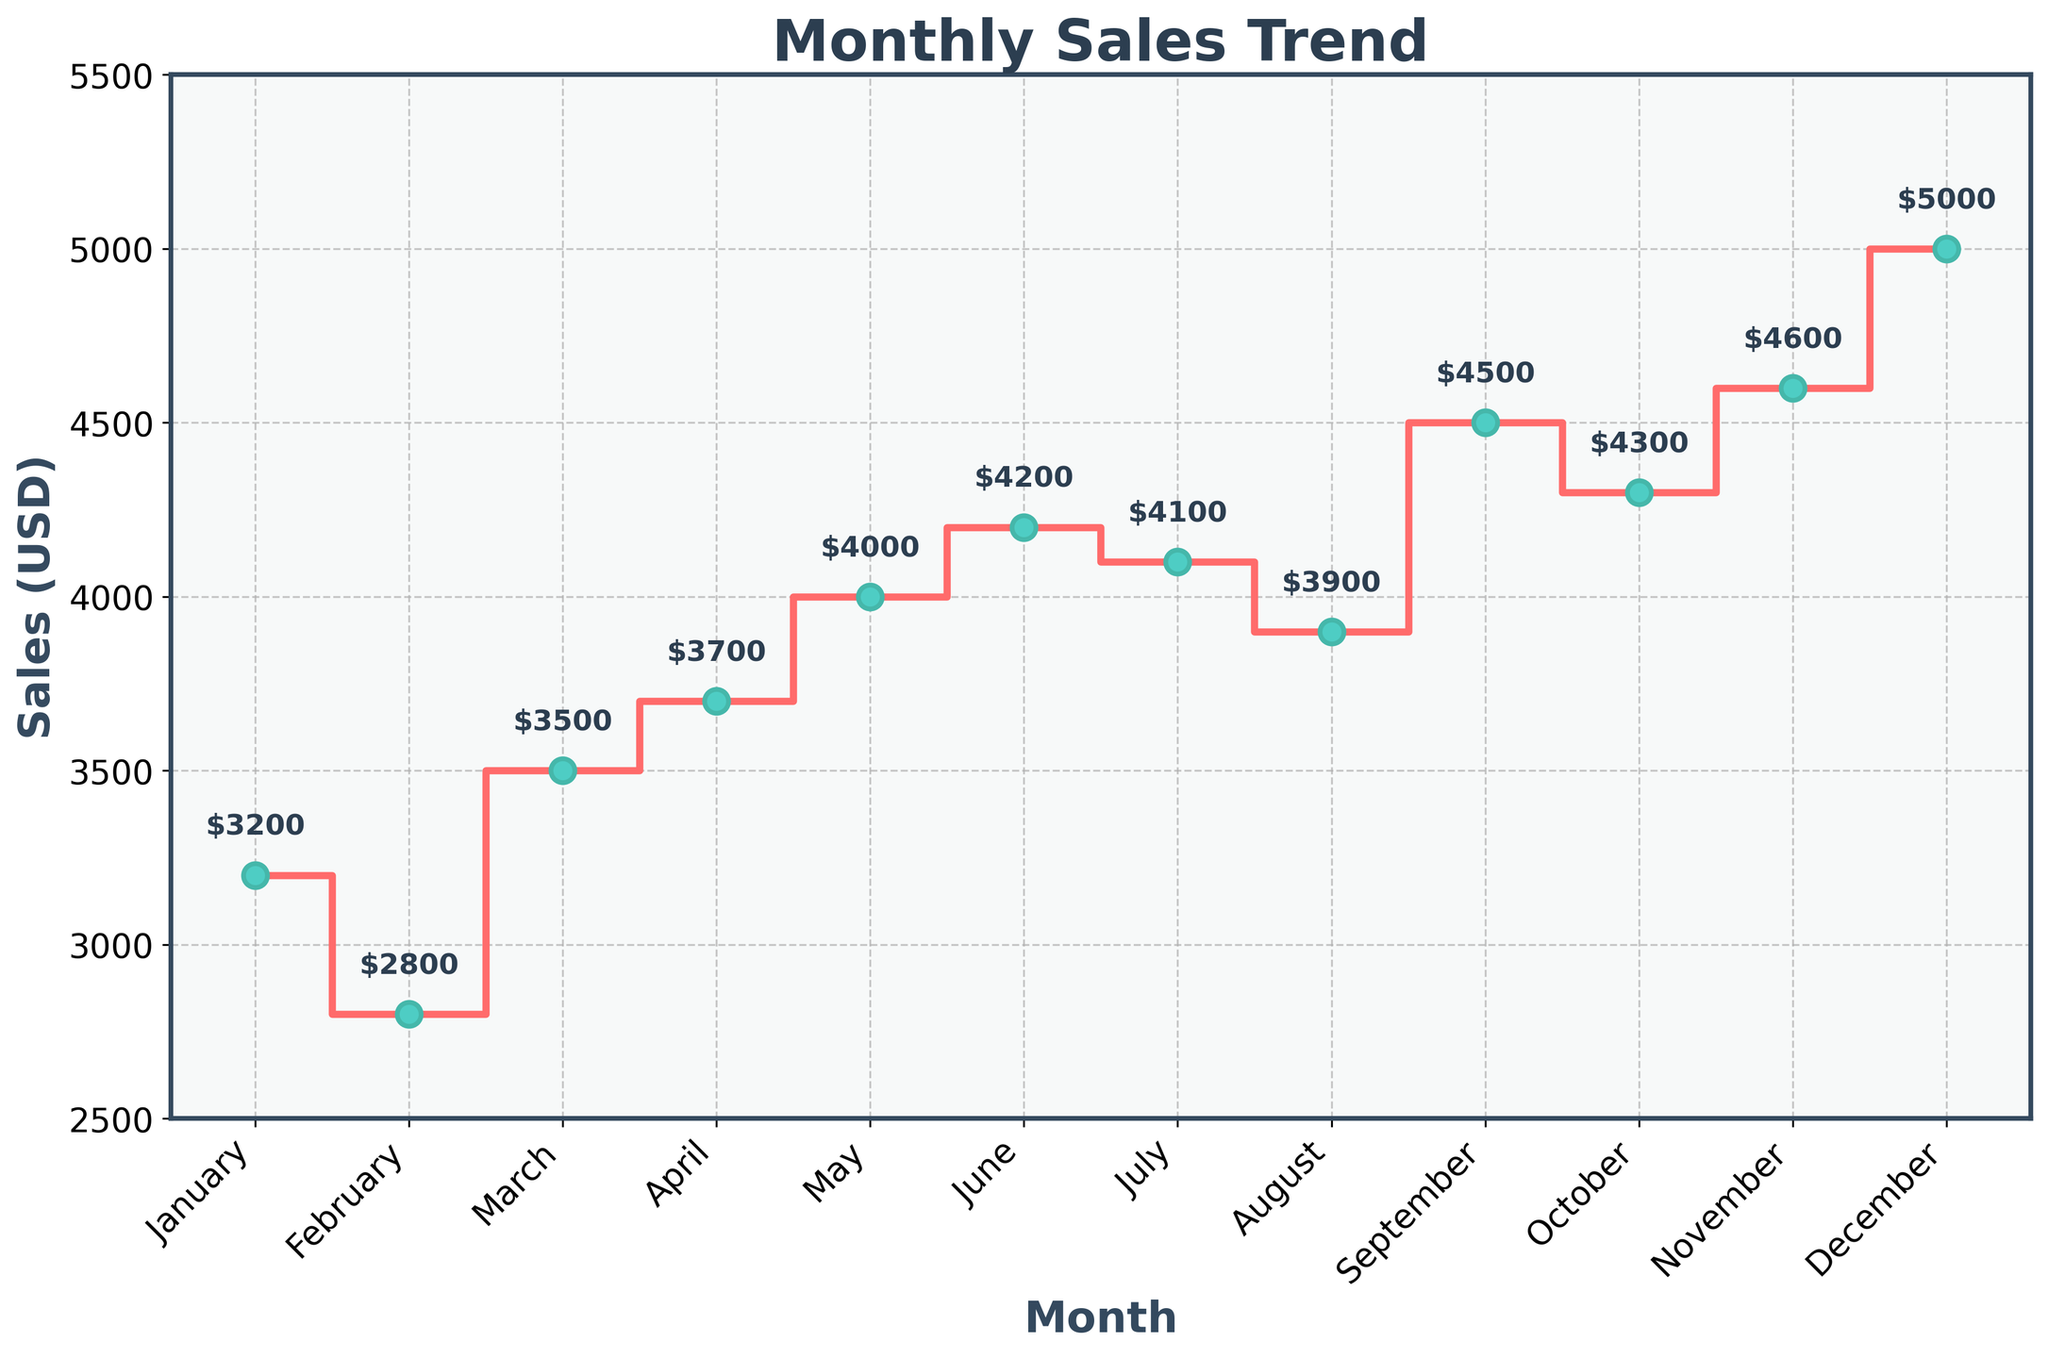What is the title of the figure? The title of the figure is located at the top and is meant to summarize what the graph is about. Here, it is titled "Monthly Sales Trend," which indicates the data represents sales throughout the year.
Answer: Monthly Sales Trend What are the units on the y-axis? The label on the y-axis specifies the units of the values plotted. In this case, the y-axis is labeled "Sales (USD)," indicating that the values represent sales in US dollars.
Answer: Sales (USD) How many data points are plotted in the stair plot? By counting the months on the x-axis or the markers along the stair plot, we can determine the number of data points given for each month. Here, each month from January to December is represented, totaling 12 data points.
Answer: 12 Which month had the highest sales? To find the month with the highest sales, we need to identify the maximum value on the stair plot and see which month it corresponds to. The highest value on the y-axis is 5000 USD in December.
Answer: December Which months had sales greater than 4000 USD? By looking at the stair plot and identifying the segments where the sales are above 4000 USD, we can list the corresponding months. In this case, the months are September (4500), October (4300), November (4600), and December (5000).
Answer: September, October, November, December What is the average sales value across all months? To find the average sales value, sum the sales for all months and divide by the number of months. The total sales are 3200 + 2800 + 3500 + 3700 + 4000 + 4200 + 4100 + 3900 + 4500 + 4300 + 4600 + 5000 = 46800 USD. Dividing this by 12 gives an average of 46800 / 12 = 3900 USD.
Answer: 3900 USD How do the sales in July compare to those in January? We need to look at the y-values for January and July and compare them. January has sales of 3200 USD, while July has 4100 USD. Thus, sales in July are higher than in January.
Answer: Sales in July are higher By how much did the sales increase from February to March? To find the increase, subtract the sales value of February from that of March. February's sales are 2800 USD, and March's sales are 3500 USD. The increase is 3500 - 2800 = 700 USD.
Answer: 700 USD Which month shows the sharpest increase in sales? Identify the month-to-month differences in sales and look for the largest increase. The most significant increase is from November (4600) to December (5000), giving an increase of 5000 - 4600 = 400 USD.
Answer: November to December Describe the general trend observed in the stair plot. The stair plot shows the sales values for each month, with markers indicating specific points. Generally, the sales trend sees incremental growth with a few fluctuations. There is an initial dip from January to February, followed by a general upward slope, with a significant rise towards the end of the year in December.
Answer: Incremental growth with fluctuations, peaks in December 